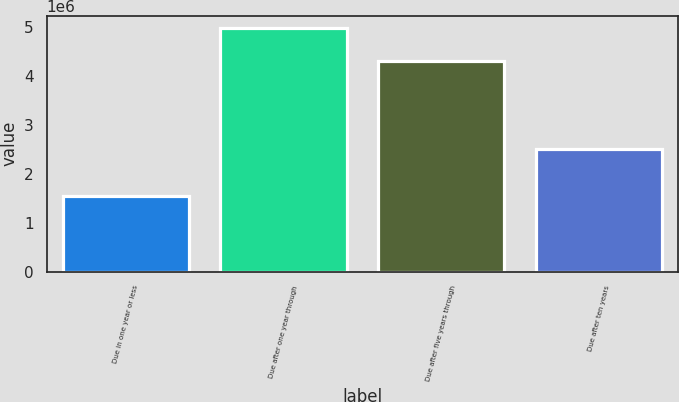Convert chart to OTSL. <chart><loc_0><loc_0><loc_500><loc_500><bar_chart><fcel>Due in one year or less<fcel>Due after one year through<fcel>Due after five years through<fcel>Due after ten years<nl><fcel>1.54868e+06<fcel>4.9714e+06<fcel>4.30537e+06<fcel>2.51085e+06<nl></chart> 